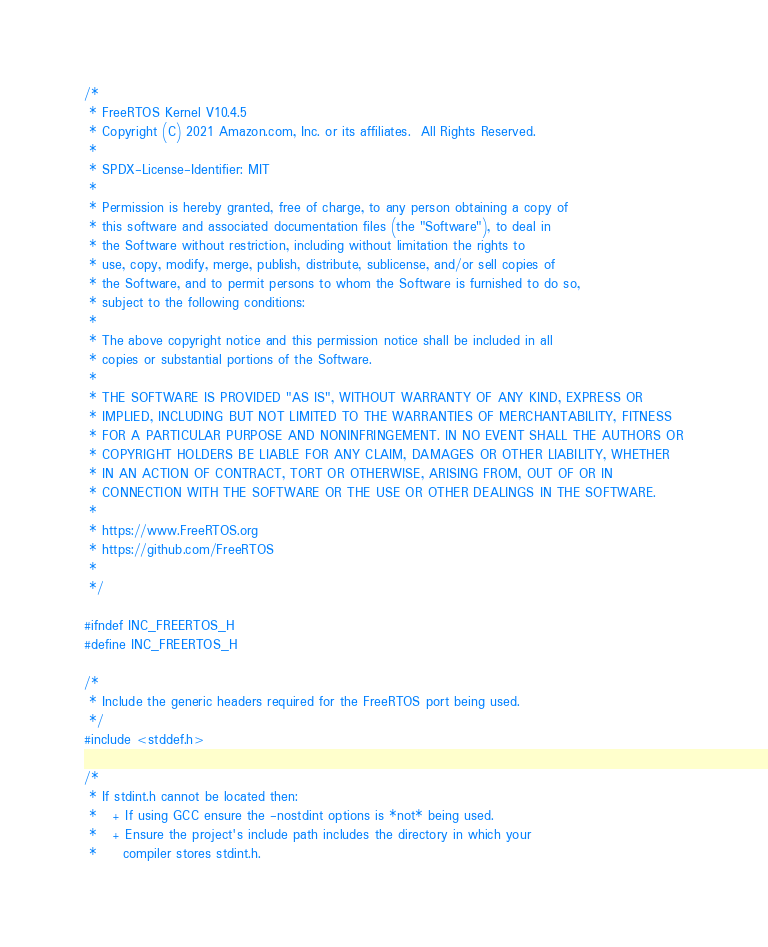Convert code to text. <code><loc_0><loc_0><loc_500><loc_500><_C_>/*
 * FreeRTOS Kernel V10.4.5
 * Copyright (C) 2021 Amazon.com, Inc. or its affiliates.  All Rights Reserved.
 *
 * SPDX-License-Identifier: MIT
 *
 * Permission is hereby granted, free of charge, to any person obtaining a copy of
 * this software and associated documentation files (the "Software"), to deal in
 * the Software without restriction, including without limitation the rights to
 * use, copy, modify, merge, publish, distribute, sublicense, and/or sell copies of
 * the Software, and to permit persons to whom the Software is furnished to do so,
 * subject to the following conditions:
 *
 * The above copyright notice and this permission notice shall be included in all
 * copies or substantial portions of the Software.
 *
 * THE SOFTWARE IS PROVIDED "AS IS", WITHOUT WARRANTY OF ANY KIND, EXPRESS OR
 * IMPLIED, INCLUDING BUT NOT LIMITED TO THE WARRANTIES OF MERCHANTABILITY, FITNESS
 * FOR A PARTICULAR PURPOSE AND NONINFRINGEMENT. IN NO EVENT SHALL THE AUTHORS OR
 * COPYRIGHT HOLDERS BE LIABLE FOR ANY CLAIM, DAMAGES OR OTHER LIABILITY, WHETHER
 * IN AN ACTION OF CONTRACT, TORT OR OTHERWISE, ARISING FROM, OUT OF OR IN
 * CONNECTION WITH THE SOFTWARE OR THE USE OR OTHER DEALINGS IN THE SOFTWARE.
 *
 * https://www.FreeRTOS.org
 * https://github.com/FreeRTOS
 *
 */

#ifndef INC_FREERTOS_H
#define INC_FREERTOS_H

/*
 * Include the generic headers required for the FreeRTOS port being used.
 */
#include <stddef.h>

/*
 * If stdint.h cannot be located then:
 *   + If using GCC ensure the -nostdint options is *not* being used.
 *   + Ensure the project's include path includes the directory in which your
 *     compiler stores stdint.h.</code> 